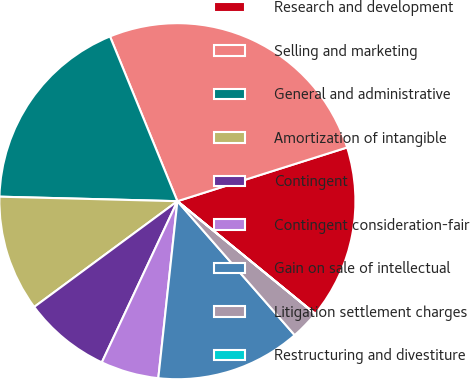Convert chart. <chart><loc_0><loc_0><loc_500><loc_500><pie_chart><fcel>Research and development<fcel>Selling and marketing<fcel>General and administrative<fcel>Amortization of intangible<fcel>Contingent<fcel>Contingent consideration-fair<fcel>Gain on sale of intellectual<fcel>Litigation settlement charges<fcel>Restructuring and divestiture<nl><fcel>15.79%<fcel>26.31%<fcel>18.42%<fcel>10.53%<fcel>7.9%<fcel>5.27%<fcel>13.16%<fcel>2.64%<fcel>0.01%<nl></chart> 